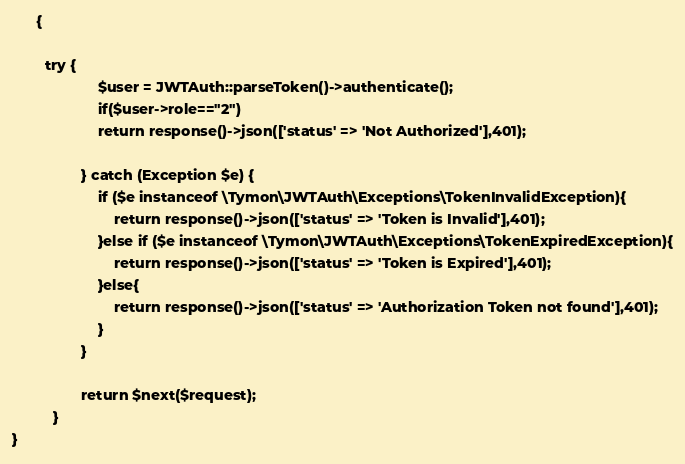Convert code to text. <code><loc_0><loc_0><loc_500><loc_500><_PHP_>
      {

        try {
                     $user = JWTAuth::parseToken()->authenticate();
                     if($user->role=="2")
                     return response()->json(['status' => 'Not Authorized'],401);

                 } catch (Exception $e) {
                     if ($e instanceof \Tymon\JWTAuth\Exceptions\TokenInvalidException){
                         return response()->json(['status' => 'Token is Invalid'],401);
                     }else if ($e instanceof \Tymon\JWTAuth\Exceptions\TokenExpiredException){
                         return response()->json(['status' => 'Token is Expired'],401);
                     }else{
                         return response()->json(['status' => 'Authorization Token not found'],401);
                     }
                 }

                 return $next($request);
          }
}
</code> 